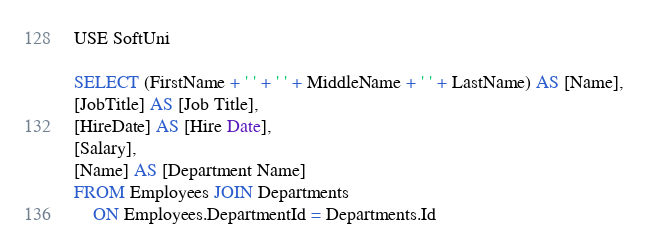<code> <loc_0><loc_0><loc_500><loc_500><_SQL_>USE SoftUni

SELECT (FirstName + ' ' + ' ' + MiddleName + ' ' + LastName) AS [Name],
[JobTitle] AS [Job Title],
[HireDate] AS [Hire Date],
[Salary],
[Name] AS [Department Name]
FROM Employees JOIN Departments 
	ON Employees.DepartmentId = Departments.Id</code> 